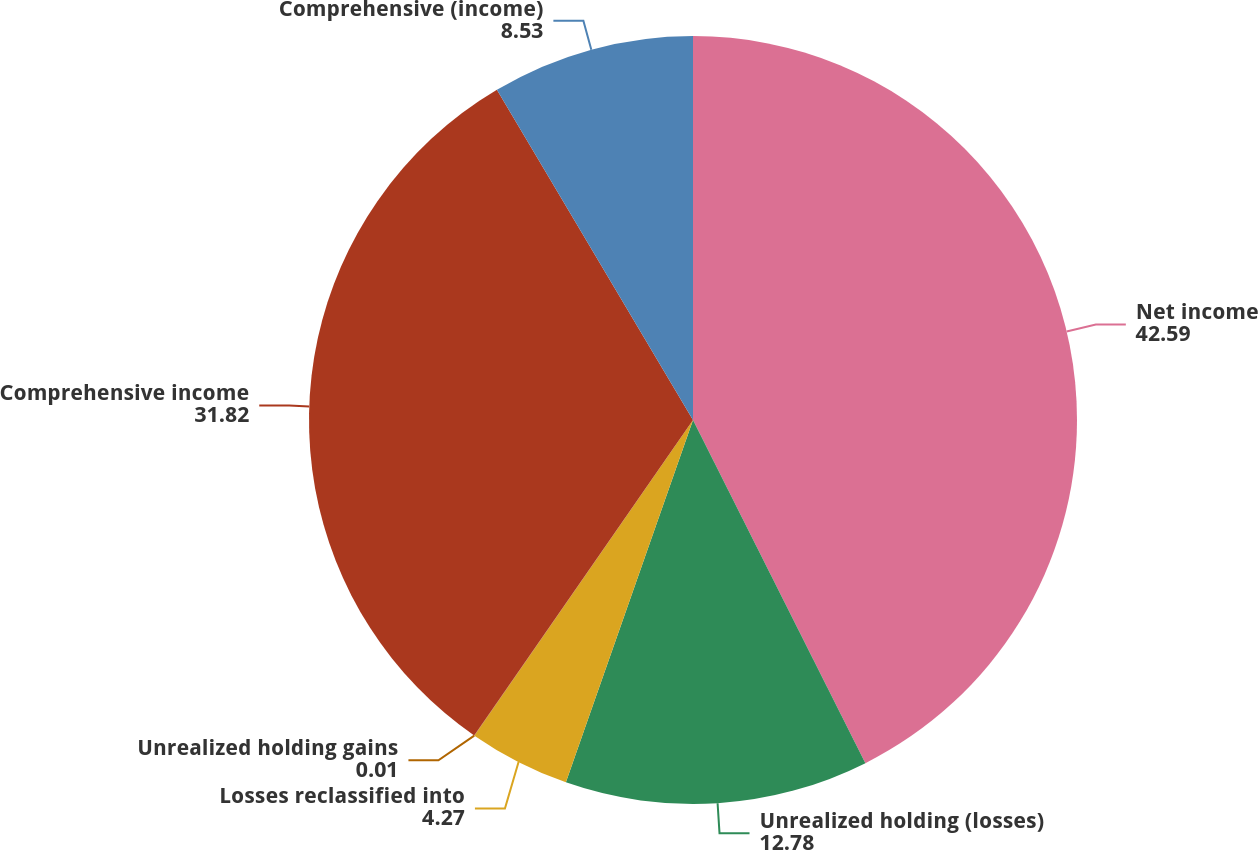<chart> <loc_0><loc_0><loc_500><loc_500><pie_chart><fcel>Net income<fcel>Unrealized holding (losses)<fcel>Losses reclassified into<fcel>Unrealized holding gains<fcel>Comprehensive income<fcel>Comprehensive (income)<nl><fcel>42.59%<fcel>12.78%<fcel>4.27%<fcel>0.01%<fcel>31.82%<fcel>8.53%<nl></chart> 